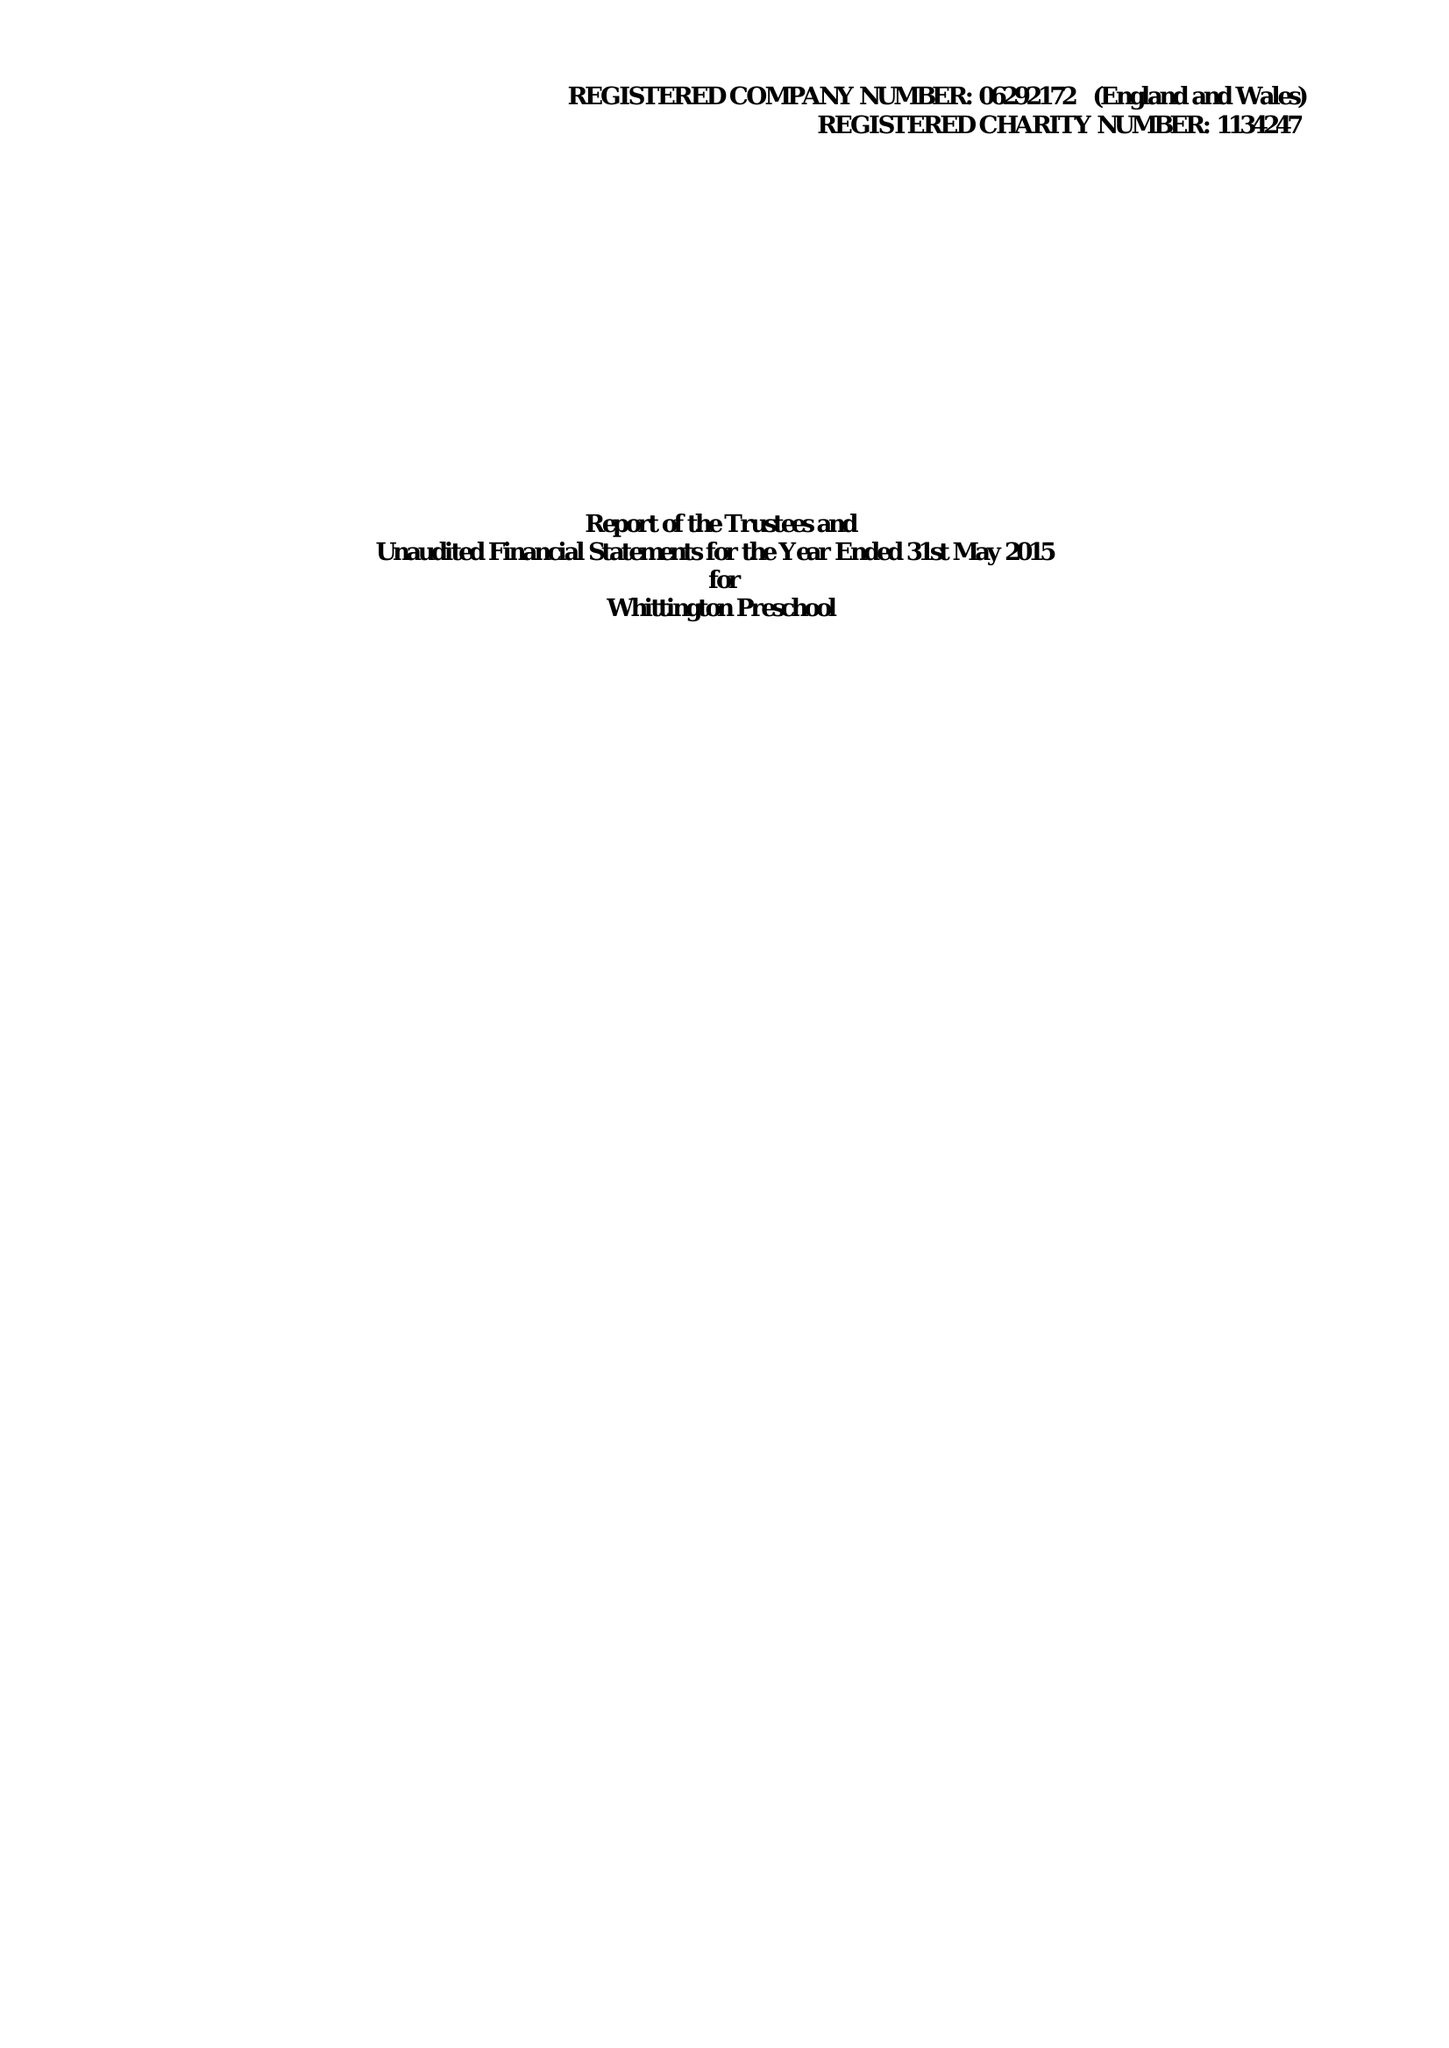What is the value for the address__postcode?
Answer the question using a single word or phrase. WS14 9PY 